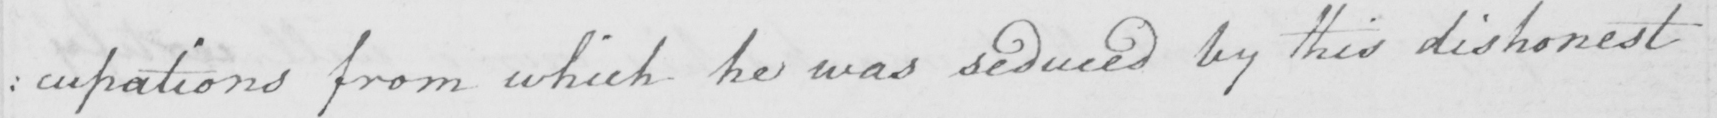What text is written in this handwritten line? : cupations from which he was seduced by this dishonest 